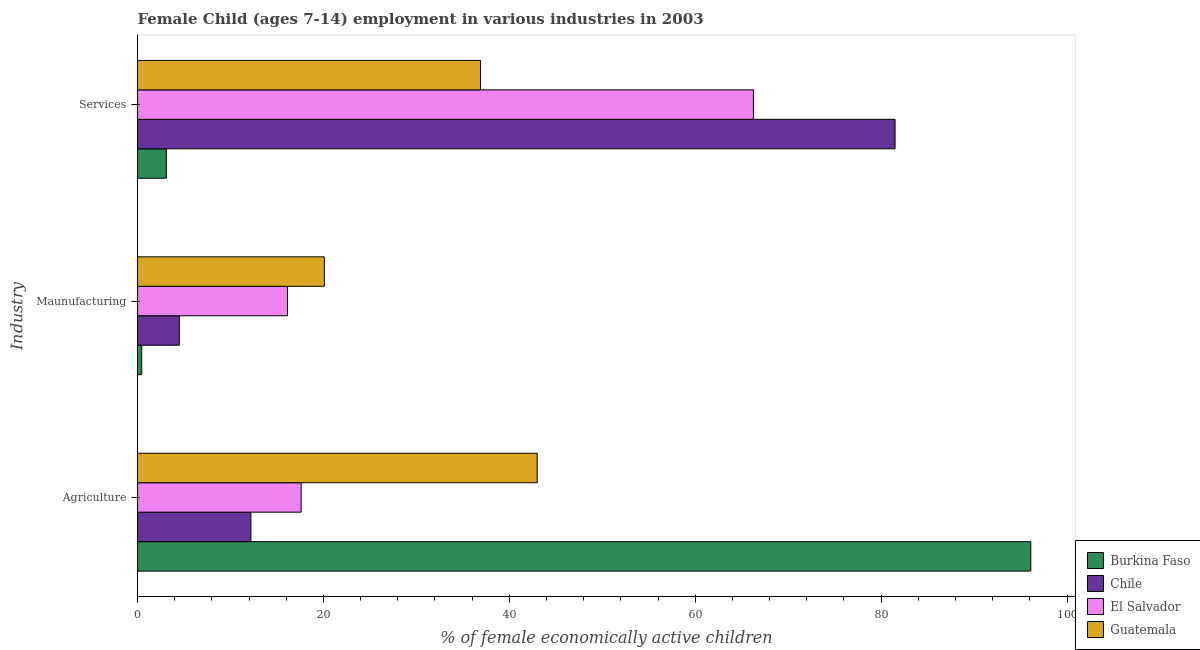Are the number of bars per tick equal to the number of legend labels?
Your answer should be compact. Yes. Are the number of bars on each tick of the Y-axis equal?
Offer a very short reply. Yes. What is the label of the 1st group of bars from the top?
Give a very brief answer. Services. Across all countries, what is the maximum percentage of economically active children in services?
Make the answer very short. 81.5. Across all countries, what is the minimum percentage of economically active children in services?
Keep it short and to the point. 3.1. In which country was the percentage of economically active children in agriculture maximum?
Your answer should be very brief. Burkina Faso. In which country was the percentage of economically active children in services minimum?
Your response must be concise. Burkina Faso. What is the total percentage of economically active children in agriculture in the graph?
Your answer should be very brief. 168.91. What is the difference between the percentage of economically active children in manufacturing in Burkina Faso and that in Chile?
Provide a short and direct response. -4.05. What is the difference between the percentage of economically active children in agriculture in Chile and the percentage of economically active children in manufacturing in El Salvador?
Ensure brevity in your answer.  -3.93. What is the average percentage of economically active children in services per country?
Ensure brevity in your answer.  46.94. What is the difference between the percentage of economically active children in services and percentage of economically active children in agriculture in Burkina Faso?
Your answer should be compact. -93. In how many countries, is the percentage of economically active children in services greater than 4 %?
Keep it short and to the point. 3. What is the ratio of the percentage of economically active children in services in Guatemala to that in Chile?
Your answer should be very brief. 0.45. What is the difference between the highest and the second highest percentage of economically active children in services?
Your answer should be compact. 15.24. What is the difference between the highest and the lowest percentage of economically active children in services?
Provide a short and direct response. 78.4. What does the 2nd bar from the top in Services represents?
Ensure brevity in your answer.  El Salvador. What does the 3rd bar from the bottom in Agriculture represents?
Keep it short and to the point. El Salvador. Does the graph contain grids?
Ensure brevity in your answer.  No. Where does the legend appear in the graph?
Keep it short and to the point. Bottom right. How many legend labels are there?
Provide a succinct answer. 4. What is the title of the graph?
Provide a short and direct response. Female Child (ages 7-14) employment in various industries in 2003. What is the label or title of the X-axis?
Make the answer very short. % of female economically active children. What is the label or title of the Y-axis?
Your response must be concise. Industry. What is the % of female economically active children of Burkina Faso in Agriculture?
Your answer should be compact. 96.1. What is the % of female economically active children in El Salvador in Agriculture?
Offer a very short reply. 17.61. What is the % of female economically active children of Burkina Faso in Maunufacturing?
Your answer should be compact. 0.45. What is the % of female economically active children in El Salvador in Maunufacturing?
Provide a succinct answer. 16.13. What is the % of female economically active children in Guatemala in Maunufacturing?
Give a very brief answer. 20.1. What is the % of female economically active children of Chile in Services?
Keep it short and to the point. 81.5. What is the % of female economically active children of El Salvador in Services?
Provide a succinct answer. 66.26. What is the % of female economically active children in Guatemala in Services?
Keep it short and to the point. 36.9. Across all Industry, what is the maximum % of female economically active children of Burkina Faso?
Offer a terse response. 96.1. Across all Industry, what is the maximum % of female economically active children of Chile?
Your response must be concise. 81.5. Across all Industry, what is the maximum % of female economically active children of El Salvador?
Your response must be concise. 66.26. Across all Industry, what is the minimum % of female economically active children of Burkina Faso?
Keep it short and to the point. 0.45. Across all Industry, what is the minimum % of female economically active children in El Salvador?
Offer a very short reply. 16.13. Across all Industry, what is the minimum % of female economically active children in Guatemala?
Keep it short and to the point. 20.1. What is the total % of female economically active children in Burkina Faso in the graph?
Keep it short and to the point. 99.65. What is the total % of female economically active children in Chile in the graph?
Your answer should be compact. 98.2. What is the total % of female economically active children in El Salvador in the graph?
Offer a very short reply. 100. What is the difference between the % of female economically active children in Burkina Faso in Agriculture and that in Maunufacturing?
Make the answer very short. 95.65. What is the difference between the % of female economically active children in Chile in Agriculture and that in Maunufacturing?
Your answer should be compact. 7.7. What is the difference between the % of female economically active children of El Salvador in Agriculture and that in Maunufacturing?
Offer a very short reply. 1.47. What is the difference between the % of female economically active children in Guatemala in Agriculture and that in Maunufacturing?
Keep it short and to the point. 22.9. What is the difference between the % of female economically active children of Burkina Faso in Agriculture and that in Services?
Offer a very short reply. 93. What is the difference between the % of female economically active children of Chile in Agriculture and that in Services?
Offer a terse response. -69.3. What is the difference between the % of female economically active children of El Salvador in Agriculture and that in Services?
Make the answer very short. -48.66. What is the difference between the % of female economically active children of Burkina Faso in Maunufacturing and that in Services?
Your response must be concise. -2.65. What is the difference between the % of female economically active children in Chile in Maunufacturing and that in Services?
Your answer should be very brief. -77. What is the difference between the % of female economically active children of El Salvador in Maunufacturing and that in Services?
Give a very brief answer. -50.13. What is the difference between the % of female economically active children of Guatemala in Maunufacturing and that in Services?
Make the answer very short. -16.8. What is the difference between the % of female economically active children in Burkina Faso in Agriculture and the % of female economically active children in Chile in Maunufacturing?
Your answer should be very brief. 91.6. What is the difference between the % of female economically active children in Burkina Faso in Agriculture and the % of female economically active children in El Salvador in Maunufacturing?
Provide a succinct answer. 79.97. What is the difference between the % of female economically active children in Chile in Agriculture and the % of female economically active children in El Salvador in Maunufacturing?
Offer a very short reply. -3.93. What is the difference between the % of female economically active children in Chile in Agriculture and the % of female economically active children in Guatemala in Maunufacturing?
Your answer should be compact. -7.9. What is the difference between the % of female economically active children of El Salvador in Agriculture and the % of female economically active children of Guatemala in Maunufacturing?
Provide a short and direct response. -2.49. What is the difference between the % of female economically active children of Burkina Faso in Agriculture and the % of female economically active children of Chile in Services?
Offer a very short reply. 14.6. What is the difference between the % of female economically active children of Burkina Faso in Agriculture and the % of female economically active children of El Salvador in Services?
Provide a succinct answer. 29.84. What is the difference between the % of female economically active children of Burkina Faso in Agriculture and the % of female economically active children of Guatemala in Services?
Your answer should be very brief. 59.2. What is the difference between the % of female economically active children of Chile in Agriculture and the % of female economically active children of El Salvador in Services?
Your answer should be very brief. -54.06. What is the difference between the % of female economically active children in Chile in Agriculture and the % of female economically active children in Guatemala in Services?
Your response must be concise. -24.7. What is the difference between the % of female economically active children of El Salvador in Agriculture and the % of female economically active children of Guatemala in Services?
Provide a short and direct response. -19.29. What is the difference between the % of female economically active children of Burkina Faso in Maunufacturing and the % of female economically active children of Chile in Services?
Provide a short and direct response. -81.05. What is the difference between the % of female economically active children in Burkina Faso in Maunufacturing and the % of female economically active children in El Salvador in Services?
Offer a very short reply. -65.81. What is the difference between the % of female economically active children in Burkina Faso in Maunufacturing and the % of female economically active children in Guatemala in Services?
Ensure brevity in your answer.  -36.45. What is the difference between the % of female economically active children in Chile in Maunufacturing and the % of female economically active children in El Salvador in Services?
Offer a very short reply. -61.76. What is the difference between the % of female economically active children in Chile in Maunufacturing and the % of female economically active children in Guatemala in Services?
Ensure brevity in your answer.  -32.4. What is the difference between the % of female economically active children in El Salvador in Maunufacturing and the % of female economically active children in Guatemala in Services?
Provide a succinct answer. -20.77. What is the average % of female economically active children of Burkina Faso per Industry?
Ensure brevity in your answer.  33.22. What is the average % of female economically active children in Chile per Industry?
Give a very brief answer. 32.73. What is the average % of female economically active children of El Salvador per Industry?
Make the answer very short. 33.33. What is the average % of female economically active children of Guatemala per Industry?
Make the answer very short. 33.33. What is the difference between the % of female economically active children in Burkina Faso and % of female economically active children in Chile in Agriculture?
Offer a terse response. 83.9. What is the difference between the % of female economically active children in Burkina Faso and % of female economically active children in El Salvador in Agriculture?
Give a very brief answer. 78.49. What is the difference between the % of female economically active children in Burkina Faso and % of female economically active children in Guatemala in Agriculture?
Make the answer very short. 53.1. What is the difference between the % of female economically active children of Chile and % of female economically active children of El Salvador in Agriculture?
Give a very brief answer. -5.41. What is the difference between the % of female economically active children of Chile and % of female economically active children of Guatemala in Agriculture?
Ensure brevity in your answer.  -30.8. What is the difference between the % of female economically active children of El Salvador and % of female economically active children of Guatemala in Agriculture?
Keep it short and to the point. -25.39. What is the difference between the % of female economically active children in Burkina Faso and % of female economically active children in Chile in Maunufacturing?
Make the answer very short. -4.05. What is the difference between the % of female economically active children in Burkina Faso and % of female economically active children in El Salvador in Maunufacturing?
Offer a very short reply. -15.68. What is the difference between the % of female economically active children in Burkina Faso and % of female economically active children in Guatemala in Maunufacturing?
Provide a short and direct response. -19.65. What is the difference between the % of female economically active children of Chile and % of female economically active children of El Salvador in Maunufacturing?
Your answer should be very brief. -11.63. What is the difference between the % of female economically active children in Chile and % of female economically active children in Guatemala in Maunufacturing?
Offer a terse response. -15.6. What is the difference between the % of female economically active children of El Salvador and % of female economically active children of Guatemala in Maunufacturing?
Make the answer very short. -3.97. What is the difference between the % of female economically active children of Burkina Faso and % of female economically active children of Chile in Services?
Your response must be concise. -78.4. What is the difference between the % of female economically active children of Burkina Faso and % of female economically active children of El Salvador in Services?
Give a very brief answer. -63.16. What is the difference between the % of female economically active children in Burkina Faso and % of female economically active children in Guatemala in Services?
Ensure brevity in your answer.  -33.8. What is the difference between the % of female economically active children in Chile and % of female economically active children in El Salvador in Services?
Keep it short and to the point. 15.24. What is the difference between the % of female economically active children in Chile and % of female economically active children in Guatemala in Services?
Your answer should be very brief. 44.6. What is the difference between the % of female economically active children in El Salvador and % of female economically active children in Guatemala in Services?
Keep it short and to the point. 29.36. What is the ratio of the % of female economically active children of Burkina Faso in Agriculture to that in Maunufacturing?
Ensure brevity in your answer.  213.2. What is the ratio of the % of female economically active children of Chile in Agriculture to that in Maunufacturing?
Your answer should be very brief. 2.71. What is the ratio of the % of female economically active children of El Salvador in Agriculture to that in Maunufacturing?
Make the answer very short. 1.09. What is the ratio of the % of female economically active children in Guatemala in Agriculture to that in Maunufacturing?
Provide a short and direct response. 2.14. What is the ratio of the % of female economically active children in Burkina Faso in Agriculture to that in Services?
Provide a succinct answer. 31. What is the ratio of the % of female economically active children of Chile in Agriculture to that in Services?
Offer a very short reply. 0.15. What is the ratio of the % of female economically active children of El Salvador in Agriculture to that in Services?
Ensure brevity in your answer.  0.27. What is the ratio of the % of female economically active children of Guatemala in Agriculture to that in Services?
Keep it short and to the point. 1.17. What is the ratio of the % of female economically active children of Burkina Faso in Maunufacturing to that in Services?
Keep it short and to the point. 0.15. What is the ratio of the % of female economically active children in Chile in Maunufacturing to that in Services?
Make the answer very short. 0.06. What is the ratio of the % of female economically active children of El Salvador in Maunufacturing to that in Services?
Provide a succinct answer. 0.24. What is the ratio of the % of female economically active children of Guatemala in Maunufacturing to that in Services?
Provide a short and direct response. 0.54. What is the difference between the highest and the second highest % of female economically active children in Burkina Faso?
Your answer should be compact. 93. What is the difference between the highest and the second highest % of female economically active children of Chile?
Offer a very short reply. 69.3. What is the difference between the highest and the second highest % of female economically active children of El Salvador?
Your response must be concise. 48.66. What is the difference between the highest and the lowest % of female economically active children of Burkina Faso?
Offer a very short reply. 95.65. What is the difference between the highest and the lowest % of female economically active children in El Salvador?
Give a very brief answer. 50.13. What is the difference between the highest and the lowest % of female economically active children in Guatemala?
Provide a succinct answer. 22.9. 